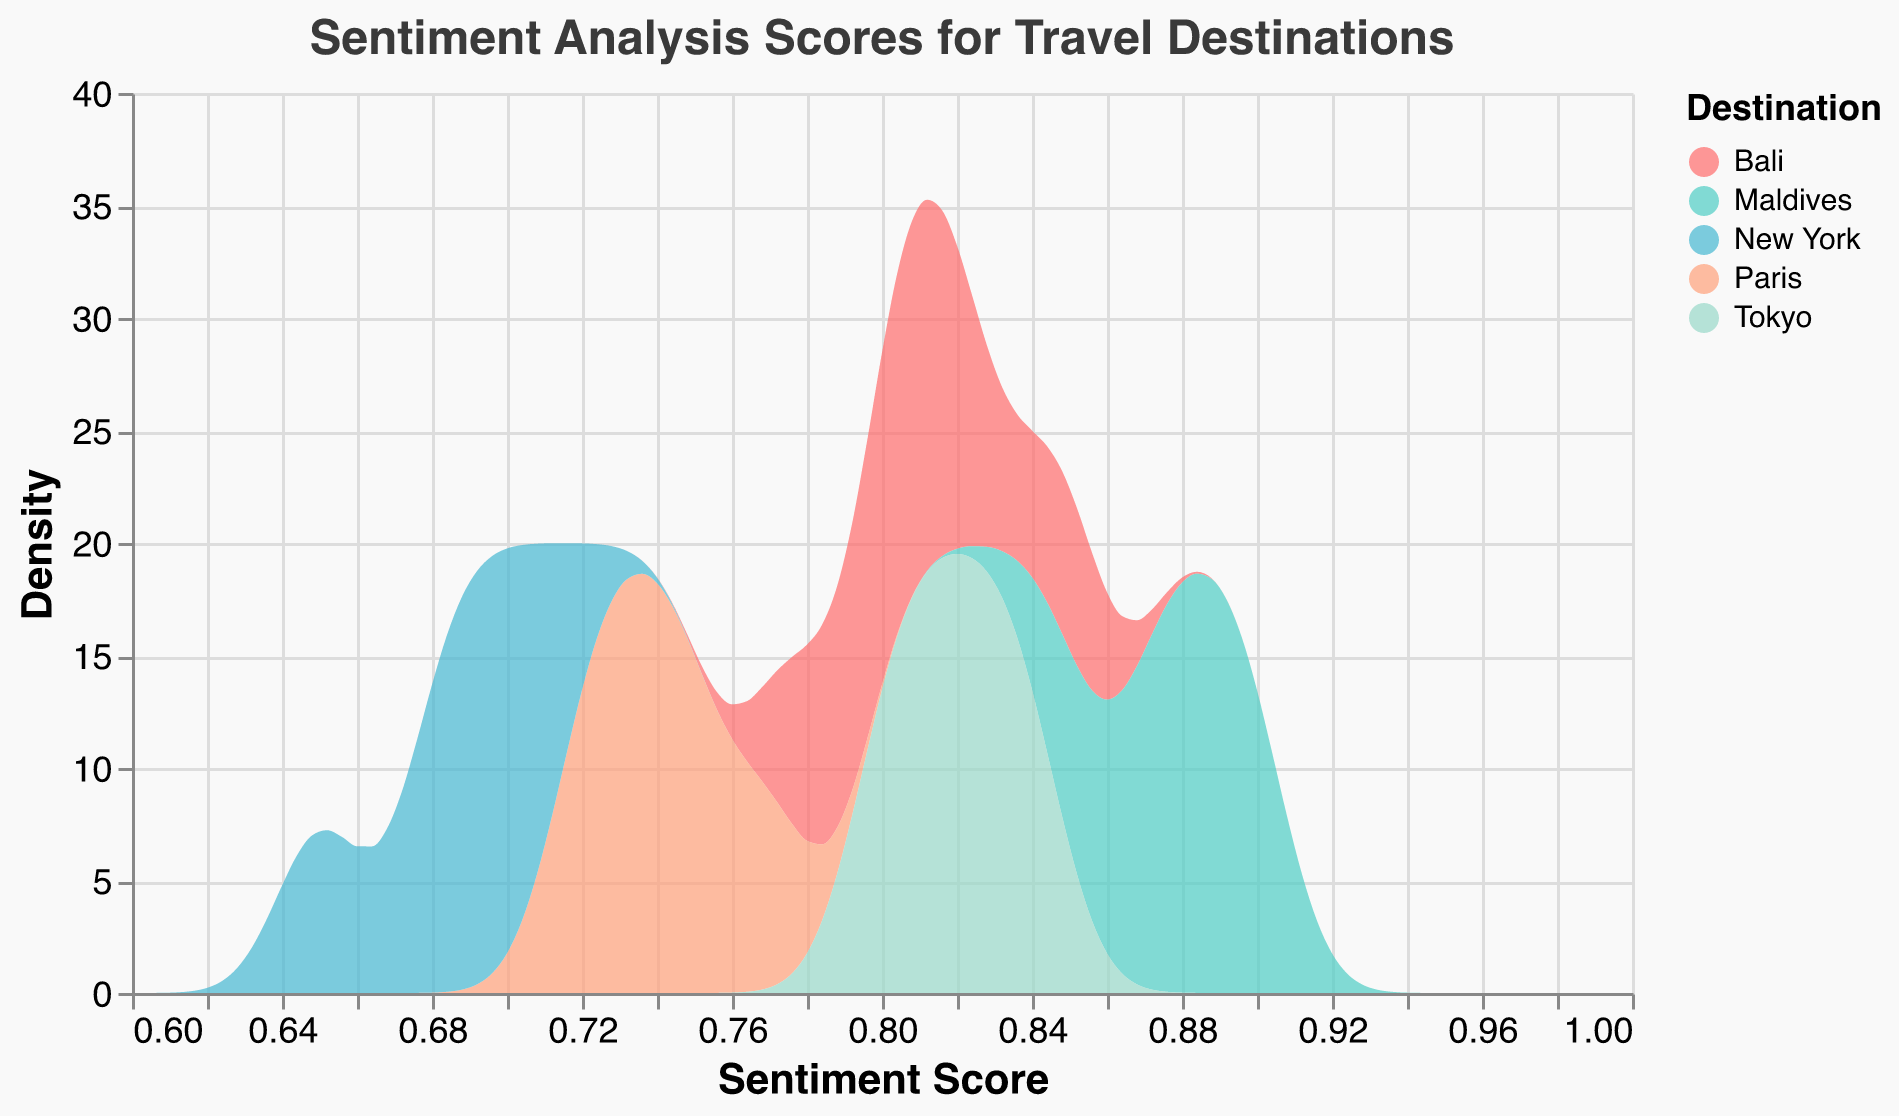What is the highest density of sentiment scores for Bali? To find the highest density for Bali, look at the curve labeled "Bali" and identify the peak value on the y-axis.
Answer: About 0.82 Between Maldives and Tokyo, which destination has a higher peak sentiment score density? Identify the peak density of the curve for Maldives and Tokyo, then compare the two. Maldives shows a higher peak than Tokyo.
Answer: Maldives Which destination shows the most variation in sentiment scores? The destination with the widest spread in the x-axis or the least sharp peak demonstrates the most variation. Examine the density curves to note the width and sharpness. Bali appears to have the most variation.
Answer: Bali What are the colors used to represent Paris and New York? Look at the legend and match the colors corresponding to Paris and New York. Paris is represented in blue, and New York in light salmon.
Answer: Blue and light salmon Which travel destination consistently has the highest sentiment scores? Look at the density plots to see which has the densest areas primarily located towards the higher end of the sentiment scores. Maldives consistently has the highest sentiment scores.
Answer: Maldives What is the sentiment score range displayed on the x-axis? Examine the x-axis to note the minimum and maximum values displayed. The range is from 0.6 to 1.
Answer: 0.6 to 1 How do the density peaks of Bali and Paris compare? Identify the peaks of the density plots for Bali and Paris. Compare the heights of these peaks to determine which is higher. Bali has a higher peak than Paris.
Answer: Bali What's the average peak density height of all destinations? Find the peak densities of all destinations, sum them up, and divide by the number of destinations. Bali (0.82), Maldives (0.89), Paris (0.77), Tokyo (0.84), New York (0.71). Average = (0.82 + 0.89 + 0.77 + 0.84 + 0.71) / 5.
Answer: 0.806 